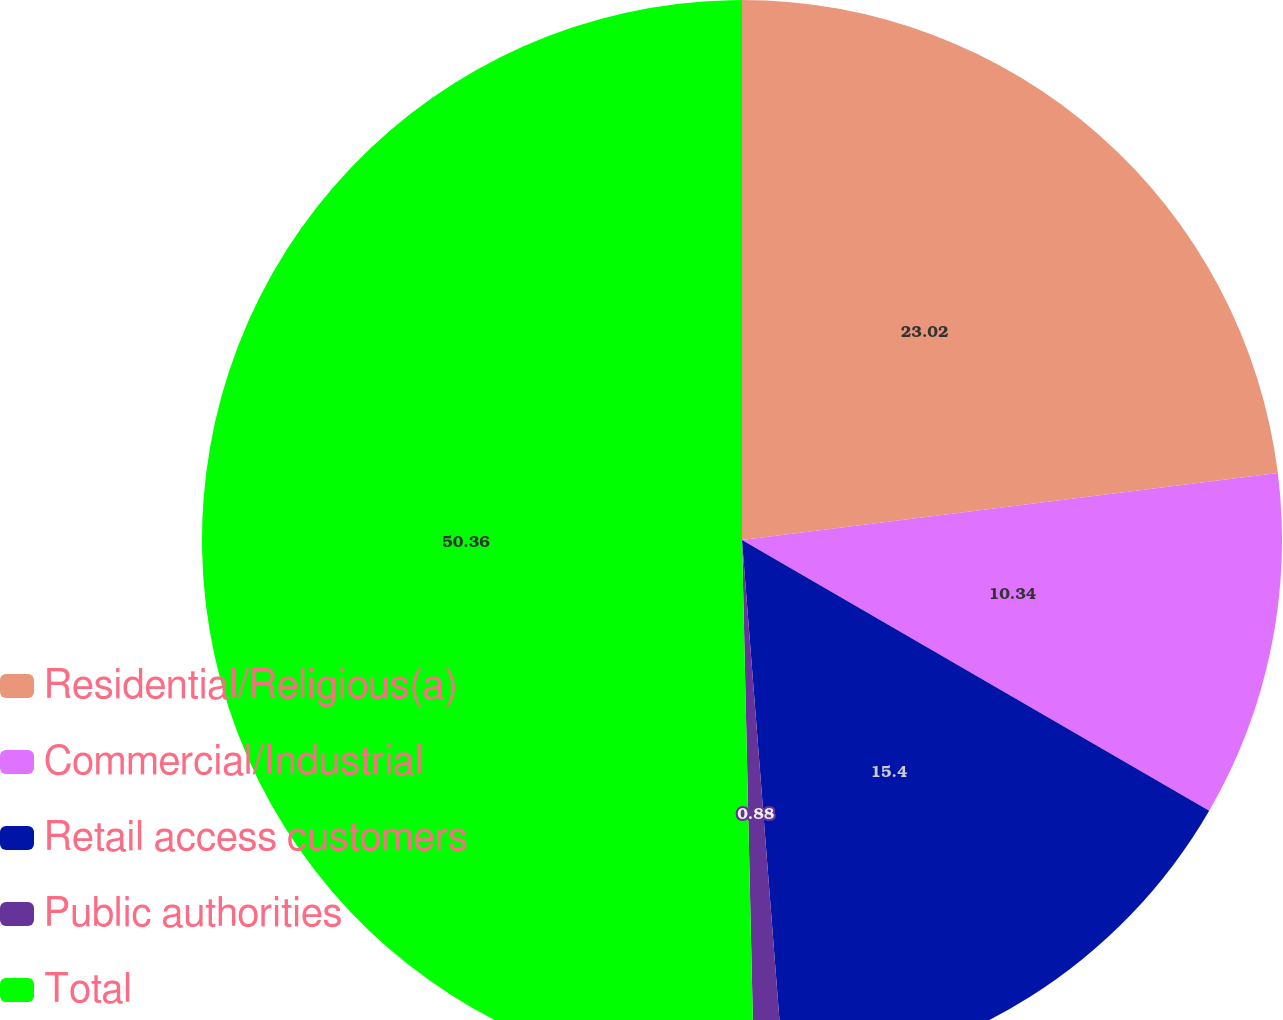Convert chart to OTSL. <chart><loc_0><loc_0><loc_500><loc_500><pie_chart><fcel>Residential/Religious(a)<fcel>Commercial/Industrial<fcel>Retail access customers<fcel>Public authorities<fcel>Total<nl><fcel>23.02%<fcel>10.34%<fcel>15.4%<fcel>0.88%<fcel>50.36%<nl></chart> 